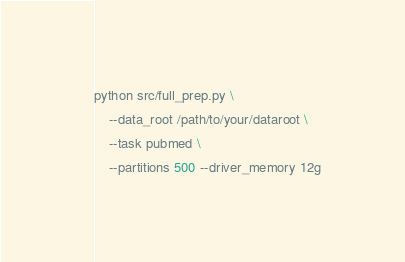Convert code to text. <code><loc_0><loc_0><loc_500><loc_500><_Bash_>python src/full_prep.py \
    --data_root /path/to/your/dataroot \
    --task pubmed \
    --partitions 500 --driver_memory 12g
</code> 